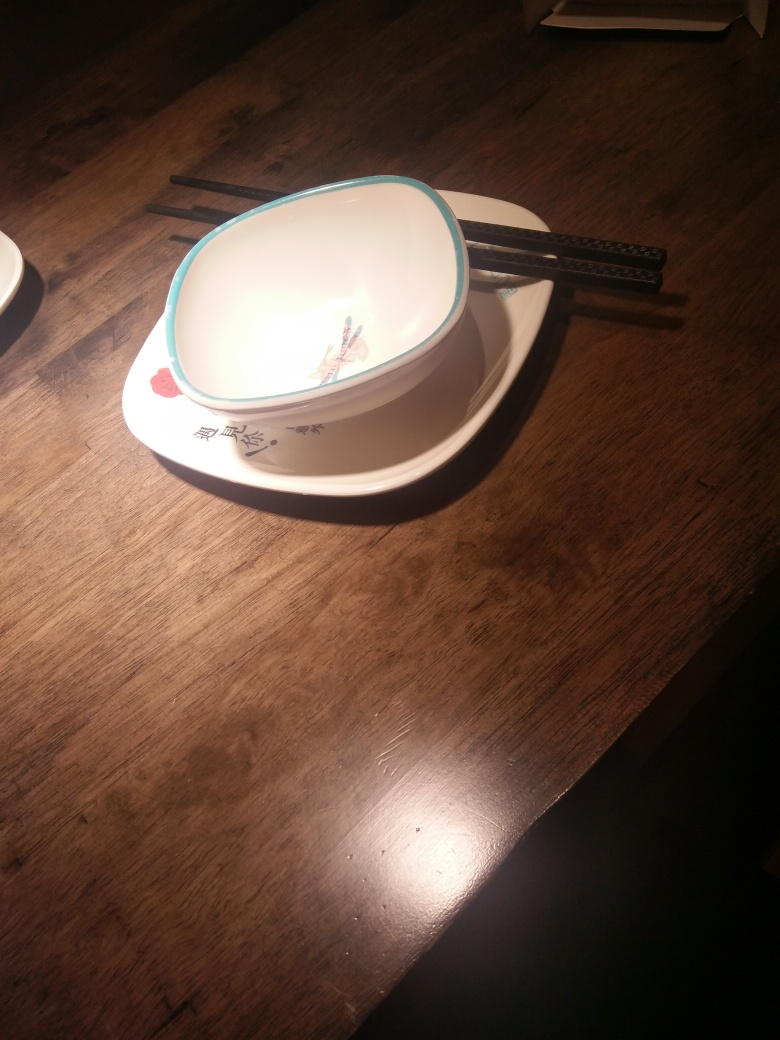What is the design on the dish? The dish features a delicate floral motif with what appears to be blossoming branches, evoking a peaceful and traditional aesthetic. 